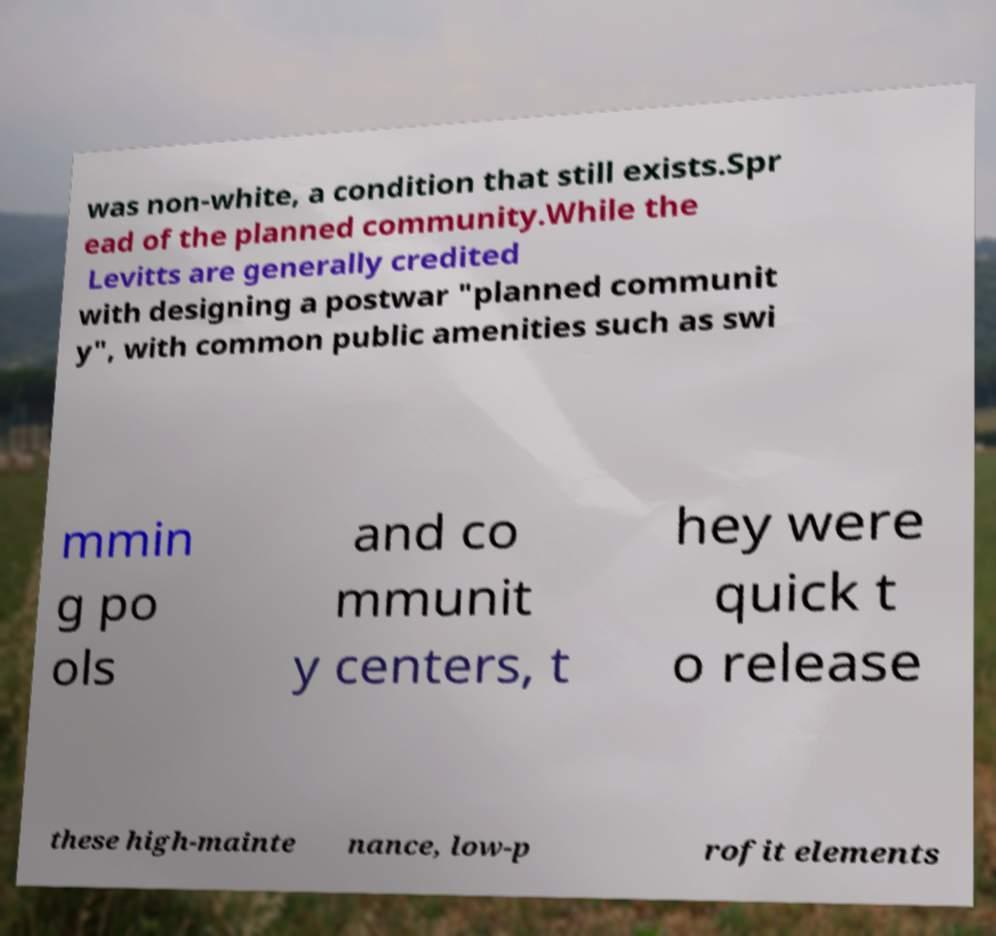Please read and relay the text visible in this image. What does it say? was non-white, a condition that still exists.Spr ead of the planned community.While the Levitts are generally credited with designing a postwar "planned communit y", with common public amenities such as swi mmin g po ols and co mmunit y centers, t hey were quick t o release these high-mainte nance, low-p rofit elements 